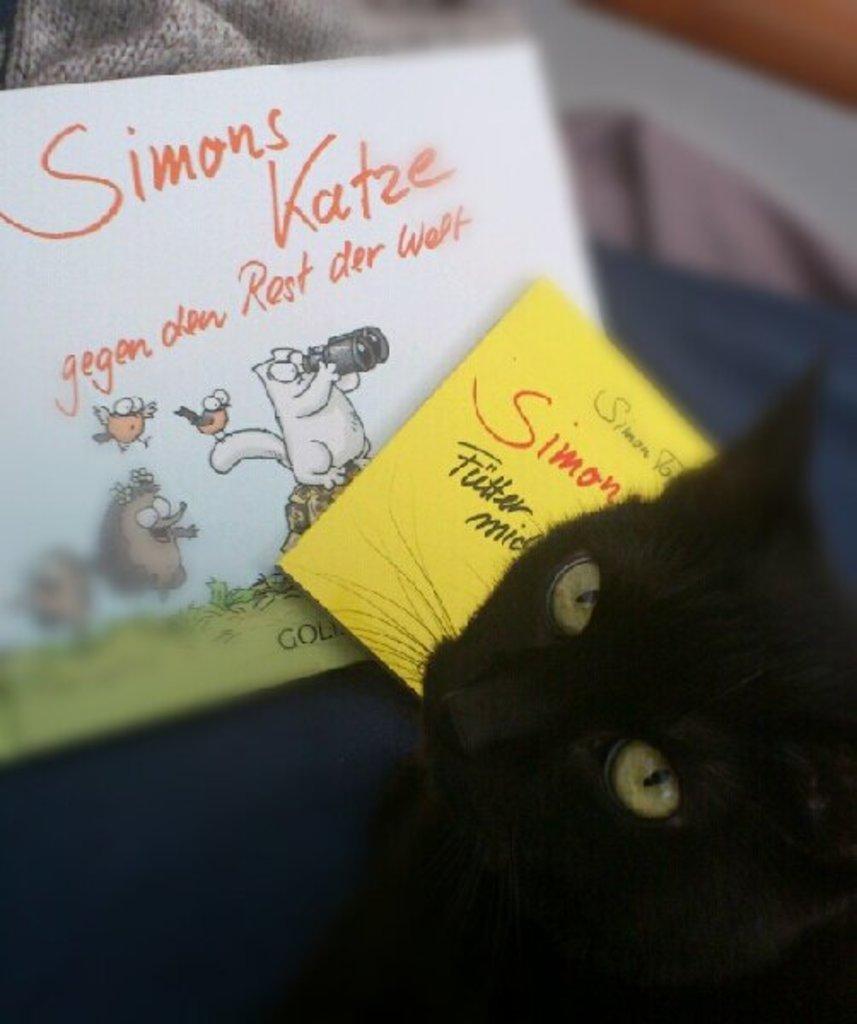Can you describe this image briefly? There is a black cat at the bottom of this image. We can see two posts are present in the middle of this image. 